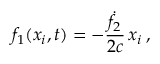<formula> <loc_0><loc_0><loc_500><loc_500>f _ { 1 } ( x _ { i } , t ) = - \frac { \dot { f } _ { 2 } } { 2 c } \, x _ { i } \, ,</formula> 